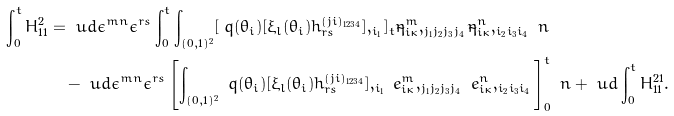<formula> <loc_0><loc_0><loc_500><loc_500>\int _ { 0 } ^ { t } H _ { 1 1 } ^ { 2 } & = \ u d \epsilon ^ { m n } \epsilon ^ { r s } \int _ { 0 } ^ { t } \int _ { ( 0 , 1 ) ^ { 2 } } [ \ q ( \theta _ { i } ) [ \xi _ { l } ( \theta _ { i } ) h _ { r s } ^ { ( j i ) _ { 1 2 3 4 } } ] , _ { i _ { 1 } } ] _ { t } \tilde { \eta } _ { i \kappa } ^ { m } , _ { j _ { 1 } j _ { 2 } j _ { 3 } j _ { 4 } } \tilde { \eta } _ { i \kappa } ^ { n } , _ { i _ { 2 } i _ { 3 } i _ { 4 } } \ n \\ & \quad - \ u d \epsilon ^ { m n } \epsilon ^ { r s } \left [ \int _ { ( 0 , 1 ) ^ { 2 } } \ q ( \theta _ { i } ) [ \xi _ { l } ( \theta _ { i } ) h _ { r s } ^ { ( j i ) _ { 1 2 3 4 } } ] , _ { i _ { 1 } } \ e _ { i \kappa } ^ { m } , _ { j _ { 1 } j _ { 2 } j _ { 3 } j _ { 4 } } \ e _ { i \kappa } ^ { n } , _ { i _ { 2 } i _ { 3 } i _ { 4 } } \right ] _ { 0 } ^ { t } \ n + \ u d \int _ { 0 } ^ { t } H _ { 1 1 } ^ { 2 1 } .</formula> 